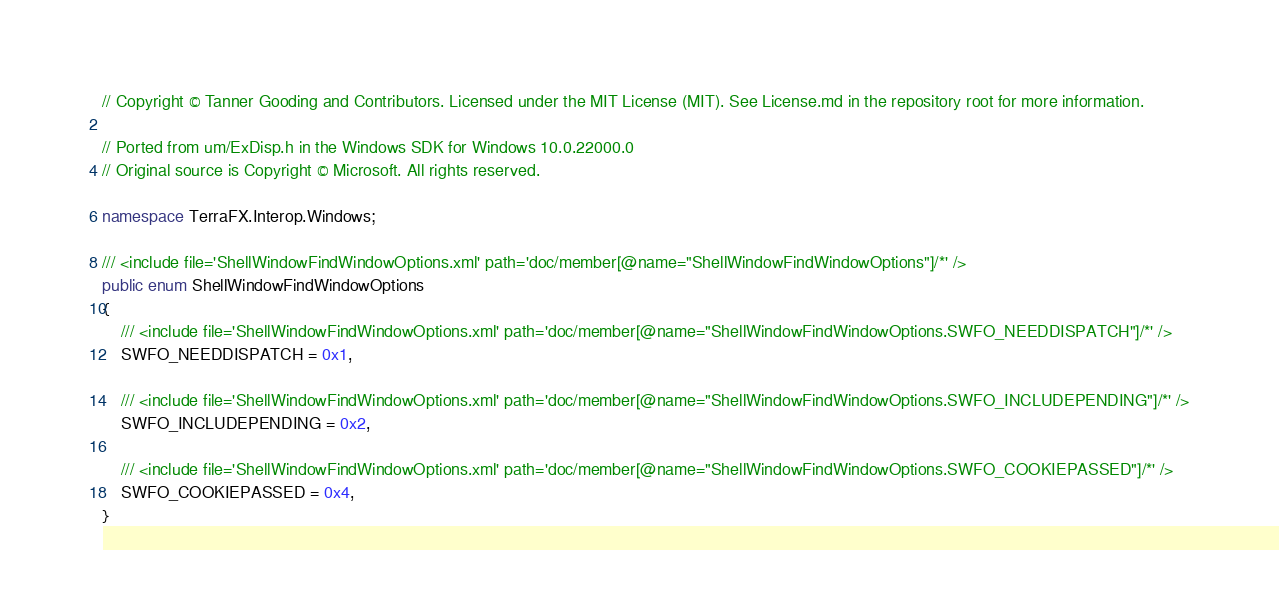<code> <loc_0><loc_0><loc_500><loc_500><_C#_>// Copyright © Tanner Gooding and Contributors. Licensed under the MIT License (MIT). See License.md in the repository root for more information.

// Ported from um/ExDisp.h in the Windows SDK for Windows 10.0.22000.0
// Original source is Copyright © Microsoft. All rights reserved.

namespace TerraFX.Interop.Windows;

/// <include file='ShellWindowFindWindowOptions.xml' path='doc/member[@name="ShellWindowFindWindowOptions"]/*' />
public enum ShellWindowFindWindowOptions
{
    /// <include file='ShellWindowFindWindowOptions.xml' path='doc/member[@name="ShellWindowFindWindowOptions.SWFO_NEEDDISPATCH"]/*' />
    SWFO_NEEDDISPATCH = 0x1,

    /// <include file='ShellWindowFindWindowOptions.xml' path='doc/member[@name="ShellWindowFindWindowOptions.SWFO_INCLUDEPENDING"]/*' />
    SWFO_INCLUDEPENDING = 0x2,

    /// <include file='ShellWindowFindWindowOptions.xml' path='doc/member[@name="ShellWindowFindWindowOptions.SWFO_COOKIEPASSED"]/*' />
    SWFO_COOKIEPASSED = 0x4,
}
</code> 